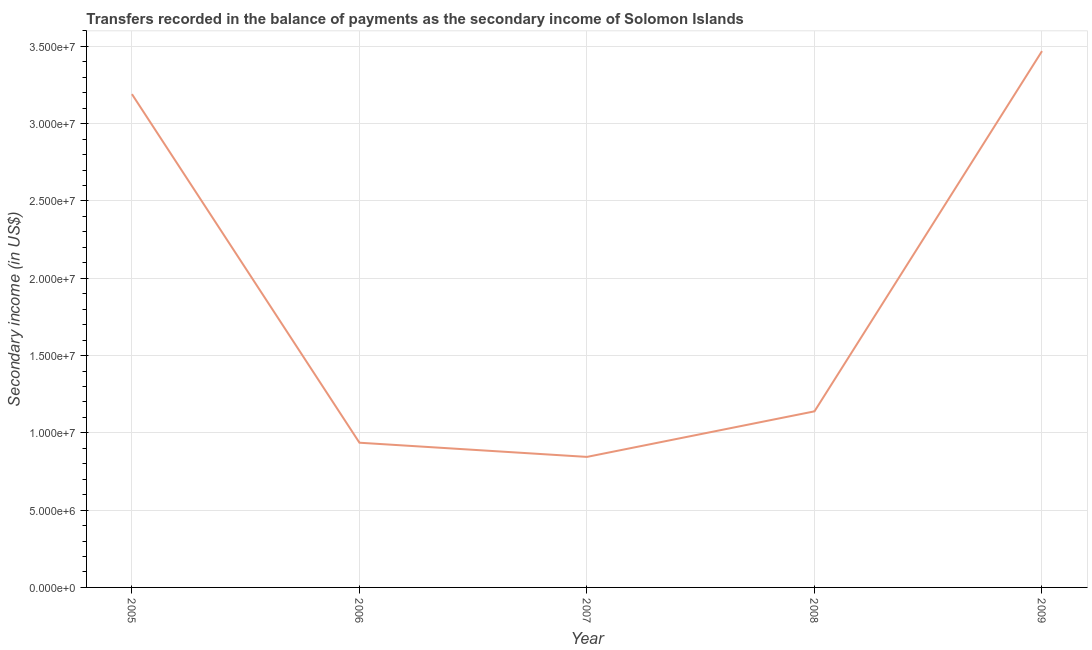What is the amount of secondary income in 2005?
Your answer should be compact. 3.19e+07. Across all years, what is the maximum amount of secondary income?
Your answer should be compact. 3.47e+07. Across all years, what is the minimum amount of secondary income?
Provide a short and direct response. 8.44e+06. In which year was the amount of secondary income maximum?
Make the answer very short. 2009. What is the sum of the amount of secondary income?
Make the answer very short. 9.58e+07. What is the difference between the amount of secondary income in 2005 and 2009?
Offer a very short reply. -2.78e+06. What is the average amount of secondary income per year?
Offer a terse response. 1.92e+07. What is the median amount of secondary income?
Your response must be concise. 1.14e+07. In how many years, is the amount of secondary income greater than 18000000 US$?
Offer a very short reply. 2. What is the ratio of the amount of secondary income in 2005 to that in 2007?
Your answer should be very brief. 3.78. What is the difference between the highest and the second highest amount of secondary income?
Give a very brief answer. 2.78e+06. What is the difference between the highest and the lowest amount of secondary income?
Provide a succinct answer. 2.62e+07. Does the amount of secondary income monotonically increase over the years?
Ensure brevity in your answer.  No. How many lines are there?
Your response must be concise. 1. How many years are there in the graph?
Your answer should be very brief. 5. Does the graph contain any zero values?
Ensure brevity in your answer.  No. What is the title of the graph?
Your answer should be very brief. Transfers recorded in the balance of payments as the secondary income of Solomon Islands. What is the label or title of the Y-axis?
Offer a terse response. Secondary income (in US$). What is the Secondary income (in US$) in 2005?
Provide a succinct answer. 3.19e+07. What is the Secondary income (in US$) of 2006?
Your answer should be compact. 9.36e+06. What is the Secondary income (in US$) of 2007?
Give a very brief answer. 8.44e+06. What is the Secondary income (in US$) of 2008?
Your answer should be compact. 1.14e+07. What is the Secondary income (in US$) of 2009?
Your answer should be very brief. 3.47e+07. What is the difference between the Secondary income (in US$) in 2005 and 2006?
Your response must be concise. 2.26e+07. What is the difference between the Secondary income (in US$) in 2005 and 2007?
Provide a short and direct response. 2.35e+07. What is the difference between the Secondary income (in US$) in 2005 and 2008?
Offer a very short reply. 2.05e+07. What is the difference between the Secondary income (in US$) in 2005 and 2009?
Ensure brevity in your answer.  -2.78e+06. What is the difference between the Secondary income (in US$) in 2006 and 2007?
Provide a succinct answer. 9.17e+05. What is the difference between the Secondary income (in US$) in 2006 and 2008?
Make the answer very short. -2.03e+06. What is the difference between the Secondary income (in US$) in 2006 and 2009?
Give a very brief answer. -2.53e+07. What is the difference between the Secondary income (in US$) in 2007 and 2008?
Offer a terse response. -2.95e+06. What is the difference between the Secondary income (in US$) in 2007 and 2009?
Ensure brevity in your answer.  -2.62e+07. What is the difference between the Secondary income (in US$) in 2008 and 2009?
Give a very brief answer. -2.33e+07. What is the ratio of the Secondary income (in US$) in 2005 to that in 2006?
Offer a very short reply. 3.41. What is the ratio of the Secondary income (in US$) in 2005 to that in 2007?
Your answer should be very brief. 3.78. What is the ratio of the Secondary income (in US$) in 2005 to that in 2008?
Offer a very short reply. 2.8. What is the ratio of the Secondary income (in US$) in 2005 to that in 2009?
Provide a succinct answer. 0.92. What is the ratio of the Secondary income (in US$) in 2006 to that in 2007?
Offer a very short reply. 1.11. What is the ratio of the Secondary income (in US$) in 2006 to that in 2008?
Your answer should be very brief. 0.82. What is the ratio of the Secondary income (in US$) in 2006 to that in 2009?
Your answer should be very brief. 0.27. What is the ratio of the Secondary income (in US$) in 2007 to that in 2008?
Provide a succinct answer. 0.74. What is the ratio of the Secondary income (in US$) in 2007 to that in 2009?
Give a very brief answer. 0.24. What is the ratio of the Secondary income (in US$) in 2008 to that in 2009?
Give a very brief answer. 0.33. 